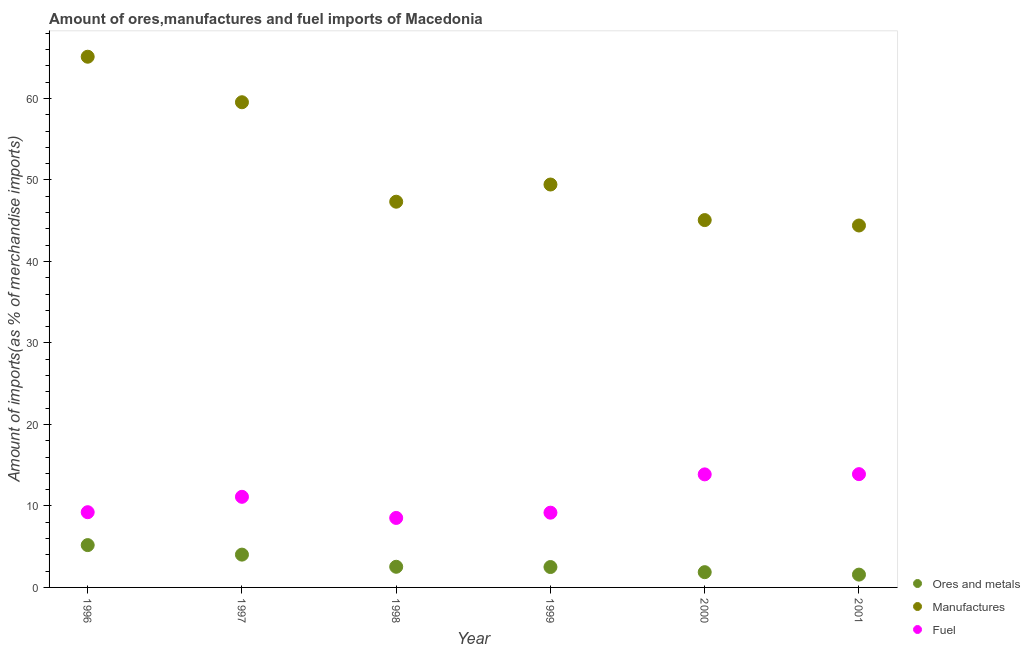How many different coloured dotlines are there?
Your answer should be compact. 3. Is the number of dotlines equal to the number of legend labels?
Ensure brevity in your answer.  Yes. What is the percentage of manufactures imports in 1996?
Your answer should be compact. 65.12. Across all years, what is the maximum percentage of manufactures imports?
Provide a succinct answer. 65.12. Across all years, what is the minimum percentage of ores and metals imports?
Provide a succinct answer. 1.57. What is the total percentage of fuel imports in the graph?
Offer a very short reply. 65.82. What is the difference between the percentage of fuel imports in 1997 and that in 1998?
Make the answer very short. 2.59. What is the difference between the percentage of ores and metals imports in 2000 and the percentage of fuel imports in 1996?
Make the answer very short. -7.36. What is the average percentage of fuel imports per year?
Offer a terse response. 10.97. In the year 2000, what is the difference between the percentage of fuel imports and percentage of ores and metals imports?
Provide a succinct answer. 12. In how many years, is the percentage of ores and metals imports greater than 52 %?
Offer a very short reply. 0. What is the ratio of the percentage of fuel imports in 1996 to that in 1998?
Provide a succinct answer. 1.08. Is the difference between the percentage of manufactures imports in 1998 and 1999 greater than the difference between the percentage of fuel imports in 1998 and 1999?
Ensure brevity in your answer.  No. What is the difference between the highest and the second highest percentage of fuel imports?
Your answer should be very brief. 0.03. What is the difference between the highest and the lowest percentage of ores and metals imports?
Provide a short and direct response. 3.62. In how many years, is the percentage of fuel imports greater than the average percentage of fuel imports taken over all years?
Offer a terse response. 3. Is the percentage of ores and metals imports strictly greater than the percentage of fuel imports over the years?
Make the answer very short. No. Is the percentage of manufactures imports strictly less than the percentage of ores and metals imports over the years?
Give a very brief answer. No. How many years are there in the graph?
Your answer should be very brief. 6. What is the difference between two consecutive major ticks on the Y-axis?
Provide a succinct answer. 10. Are the values on the major ticks of Y-axis written in scientific E-notation?
Your response must be concise. No. Where does the legend appear in the graph?
Make the answer very short. Bottom right. How many legend labels are there?
Your answer should be very brief. 3. How are the legend labels stacked?
Offer a terse response. Vertical. What is the title of the graph?
Make the answer very short. Amount of ores,manufactures and fuel imports of Macedonia. What is the label or title of the Y-axis?
Ensure brevity in your answer.  Amount of imports(as % of merchandise imports). What is the Amount of imports(as % of merchandise imports) in Ores and metals in 1996?
Ensure brevity in your answer.  5.19. What is the Amount of imports(as % of merchandise imports) in Manufactures in 1996?
Give a very brief answer. 65.12. What is the Amount of imports(as % of merchandise imports) in Fuel in 1996?
Offer a very short reply. 9.23. What is the Amount of imports(as % of merchandise imports) of Ores and metals in 1997?
Offer a terse response. 4.03. What is the Amount of imports(as % of merchandise imports) in Manufactures in 1997?
Your response must be concise. 59.54. What is the Amount of imports(as % of merchandise imports) in Fuel in 1997?
Make the answer very short. 11.12. What is the Amount of imports(as % of merchandise imports) of Ores and metals in 1998?
Provide a short and direct response. 2.53. What is the Amount of imports(as % of merchandise imports) of Manufactures in 1998?
Ensure brevity in your answer.  47.33. What is the Amount of imports(as % of merchandise imports) in Fuel in 1998?
Ensure brevity in your answer.  8.53. What is the Amount of imports(as % of merchandise imports) of Ores and metals in 1999?
Ensure brevity in your answer.  2.5. What is the Amount of imports(as % of merchandise imports) in Manufactures in 1999?
Make the answer very short. 49.44. What is the Amount of imports(as % of merchandise imports) of Fuel in 1999?
Make the answer very short. 9.17. What is the Amount of imports(as % of merchandise imports) of Ores and metals in 2000?
Give a very brief answer. 1.87. What is the Amount of imports(as % of merchandise imports) in Manufactures in 2000?
Your answer should be very brief. 45.08. What is the Amount of imports(as % of merchandise imports) in Fuel in 2000?
Make the answer very short. 13.87. What is the Amount of imports(as % of merchandise imports) of Ores and metals in 2001?
Give a very brief answer. 1.57. What is the Amount of imports(as % of merchandise imports) of Manufactures in 2001?
Offer a terse response. 44.41. What is the Amount of imports(as % of merchandise imports) of Fuel in 2001?
Ensure brevity in your answer.  13.9. Across all years, what is the maximum Amount of imports(as % of merchandise imports) in Ores and metals?
Give a very brief answer. 5.19. Across all years, what is the maximum Amount of imports(as % of merchandise imports) of Manufactures?
Provide a short and direct response. 65.12. Across all years, what is the maximum Amount of imports(as % of merchandise imports) of Fuel?
Provide a succinct answer. 13.9. Across all years, what is the minimum Amount of imports(as % of merchandise imports) in Ores and metals?
Provide a short and direct response. 1.57. Across all years, what is the minimum Amount of imports(as % of merchandise imports) in Manufactures?
Make the answer very short. 44.41. Across all years, what is the minimum Amount of imports(as % of merchandise imports) of Fuel?
Your answer should be compact. 8.53. What is the total Amount of imports(as % of merchandise imports) of Ores and metals in the graph?
Keep it short and to the point. 17.7. What is the total Amount of imports(as % of merchandise imports) of Manufactures in the graph?
Your answer should be very brief. 310.93. What is the total Amount of imports(as % of merchandise imports) of Fuel in the graph?
Offer a very short reply. 65.82. What is the difference between the Amount of imports(as % of merchandise imports) of Ores and metals in 1996 and that in 1997?
Make the answer very short. 1.17. What is the difference between the Amount of imports(as % of merchandise imports) in Manufactures in 1996 and that in 1997?
Keep it short and to the point. 5.59. What is the difference between the Amount of imports(as % of merchandise imports) in Fuel in 1996 and that in 1997?
Offer a terse response. -1.89. What is the difference between the Amount of imports(as % of merchandise imports) of Ores and metals in 1996 and that in 1998?
Your answer should be very brief. 2.66. What is the difference between the Amount of imports(as % of merchandise imports) of Manufactures in 1996 and that in 1998?
Ensure brevity in your answer.  17.79. What is the difference between the Amount of imports(as % of merchandise imports) of Fuel in 1996 and that in 1998?
Provide a succinct answer. 0.7. What is the difference between the Amount of imports(as % of merchandise imports) in Ores and metals in 1996 and that in 1999?
Make the answer very short. 2.69. What is the difference between the Amount of imports(as % of merchandise imports) in Manufactures in 1996 and that in 1999?
Keep it short and to the point. 15.68. What is the difference between the Amount of imports(as % of merchandise imports) in Fuel in 1996 and that in 1999?
Your response must be concise. 0.06. What is the difference between the Amount of imports(as % of merchandise imports) in Ores and metals in 1996 and that in 2000?
Give a very brief answer. 3.32. What is the difference between the Amount of imports(as % of merchandise imports) in Manufactures in 1996 and that in 2000?
Your answer should be very brief. 20.05. What is the difference between the Amount of imports(as % of merchandise imports) of Fuel in 1996 and that in 2000?
Your answer should be compact. -4.64. What is the difference between the Amount of imports(as % of merchandise imports) in Ores and metals in 1996 and that in 2001?
Provide a succinct answer. 3.62. What is the difference between the Amount of imports(as % of merchandise imports) in Manufactures in 1996 and that in 2001?
Provide a succinct answer. 20.71. What is the difference between the Amount of imports(as % of merchandise imports) of Fuel in 1996 and that in 2001?
Your response must be concise. -4.67. What is the difference between the Amount of imports(as % of merchandise imports) in Ores and metals in 1997 and that in 1998?
Provide a succinct answer. 1.49. What is the difference between the Amount of imports(as % of merchandise imports) of Manufactures in 1997 and that in 1998?
Ensure brevity in your answer.  12.21. What is the difference between the Amount of imports(as % of merchandise imports) of Fuel in 1997 and that in 1998?
Give a very brief answer. 2.59. What is the difference between the Amount of imports(as % of merchandise imports) in Ores and metals in 1997 and that in 1999?
Make the answer very short. 1.52. What is the difference between the Amount of imports(as % of merchandise imports) in Manufactures in 1997 and that in 1999?
Offer a very short reply. 10.1. What is the difference between the Amount of imports(as % of merchandise imports) of Fuel in 1997 and that in 1999?
Keep it short and to the point. 1.95. What is the difference between the Amount of imports(as % of merchandise imports) of Ores and metals in 1997 and that in 2000?
Your response must be concise. 2.15. What is the difference between the Amount of imports(as % of merchandise imports) in Manufactures in 1997 and that in 2000?
Offer a very short reply. 14.46. What is the difference between the Amount of imports(as % of merchandise imports) of Fuel in 1997 and that in 2000?
Keep it short and to the point. -2.75. What is the difference between the Amount of imports(as % of merchandise imports) in Ores and metals in 1997 and that in 2001?
Offer a very short reply. 2.45. What is the difference between the Amount of imports(as % of merchandise imports) of Manufactures in 1997 and that in 2001?
Offer a terse response. 15.13. What is the difference between the Amount of imports(as % of merchandise imports) of Fuel in 1997 and that in 2001?
Offer a very short reply. -2.78. What is the difference between the Amount of imports(as % of merchandise imports) in Manufactures in 1998 and that in 1999?
Offer a terse response. -2.11. What is the difference between the Amount of imports(as % of merchandise imports) of Fuel in 1998 and that in 1999?
Ensure brevity in your answer.  -0.65. What is the difference between the Amount of imports(as % of merchandise imports) of Ores and metals in 1998 and that in 2000?
Make the answer very short. 0.66. What is the difference between the Amount of imports(as % of merchandise imports) of Manufactures in 1998 and that in 2000?
Your response must be concise. 2.26. What is the difference between the Amount of imports(as % of merchandise imports) in Fuel in 1998 and that in 2000?
Provide a short and direct response. -5.34. What is the difference between the Amount of imports(as % of merchandise imports) in Manufactures in 1998 and that in 2001?
Your response must be concise. 2.92. What is the difference between the Amount of imports(as % of merchandise imports) in Fuel in 1998 and that in 2001?
Your answer should be very brief. -5.37. What is the difference between the Amount of imports(as % of merchandise imports) in Ores and metals in 1999 and that in 2000?
Give a very brief answer. 0.63. What is the difference between the Amount of imports(as % of merchandise imports) in Manufactures in 1999 and that in 2000?
Offer a very short reply. 4.37. What is the difference between the Amount of imports(as % of merchandise imports) in Fuel in 1999 and that in 2000?
Keep it short and to the point. -4.7. What is the difference between the Amount of imports(as % of merchandise imports) of Ores and metals in 1999 and that in 2001?
Give a very brief answer. 0.93. What is the difference between the Amount of imports(as % of merchandise imports) of Manufactures in 1999 and that in 2001?
Provide a succinct answer. 5.03. What is the difference between the Amount of imports(as % of merchandise imports) in Fuel in 1999 and that in 2001?
Provide a succinct answer. -4.73. What is the difference between the Amount of imports(as % of merchandise imports) of Ores and metals in 2000 and that in 2001?
Provide a succinct answer. 0.3. What is the difference between the Amount of imports(as % of merchandise imports) in Manufactures in 2000 and that in 2001?
Your answer should be very brief. 0.66. What is the difference between the Amount of imports(as % of merchandise imports) of Fuel in 2000 and that in 2001?
Your response must be concise. -0.03. What is the difference between the Amount of imports(as % of merchandise imports) of Ores and metals in 1996 and the Amount of imports(as % of merchandise imports) of Manufactures in 1997?
Offer a terse response. -54.35. What is the difference between the Amount of imports(as % of merchandise imports) of Ores and metals in 1996 and the Amount of imports(as % of merchandise imports) of Fuel in 1997?
Offer a very short reply. -5.93. What is the difference between the Amount of imports(as % of merchandise imports) of Manufactures in 1996 and the Amount of imports(as % of merchandise imports) of Fuel in 1997?
Provide a succinct answer. 54.01. What is the difference between the Amount of imports(as % of merchandise imports) in Ores and metals in 1996 and the Amount of imports(as % of merchandise imports) in Manufactures in 1998?
Provide a succinct answer. -42.14. What is the difference between the Amount of imports(as % of merchandise imports) in Ores and metals in 1996 and the Amount of imports(as % of merchandise imports) in Fuel in 1998?
Make the answer very short. -3.33. What is the difference between the Amount of imports(as % of merchandise imports) of Manufactures in 1996 and the Amount of imports(as % of merchandise imports) of Fuel in 1998?
Offer a terse response. 56.6. What is the difference between the Amount of imports(as % of merchandise imports) in Ores and metals in 1996 and the Amount of imports(as % of merchandise imports) in Manufactures in 1999?
Keep it short and to the point. -44.25. What is the difference between the Amount of imports(as % of merchandise imports) of Ores and metals in 1996 and the Amount of imports(as % of merchandise imports) of Fuel in 1999?
Your answer should be very brief. -3.98. What is the difference between the Amount of imports(as % of merchandise imports) in Manufactures in 1996 and the Amount of imports(as % of merchandise imports) in Fuel in 1999?
Ensure brevity in your answer.  55.95. What is the difference between the Amount of imports(as % of merchandise imports) in Ores and metals in 1996 and the Amount of imports(as % of merchandise imports) in Manufactures in 2000?
Offer a terse response. -39.88. What is the difference between the Amount of imports(as % of merchandise imports) in Ores and metals in 1996 and the Amount of imports(as % of merchandise imports) in Fuel in 2000?
Provide a short and direct response. -8.68. What is the difference between the Amount of imports(as % of merchandise imports) of Manufactures in 1996 and the Amount of imports(as % of merchandise imports) of Fuel in 2000?
Provide a succinct answer. 51.25. What is the difference between the Amount of imports(as % of merchandise imports) of Ores and metals in 1996 and the Amount of imports(as % of merchandise imports) of Manufactures in 2001?
Provide a short and direct response. -39.22. What is the difference between the Amount of imports(as % of merchandise imports) in Ores and metals in 1996 and the Amount of imports(as % of merchandise imports) in Fuel in 2001?
Your answer should be very brief. -8.71. What is the difference between the Amount of imports(as % of merchandise imports) of Manufactures in 1996 and the Amount of imports(as % of merchandise imports) of Fuel in 2001?
Offer a terse response. 51.22. What is the difference between the Amount of imports(as % of merchandise imports) in Ores and metals in 1997 and the Amount of imports(as % of merchandise imports) in Manufactures in 1998?
Provide a succinct answer. -43.31. What is the difference between the Amount of imports(as % of merchandise imports) of Ores and metals in 1997 and the Amount of imports(as % of merchandise imports) of Fuel in 1998?
Keep it short and to the point. -4.5. What is the difference between the Amount of imports(as % of merchandise imports) of Manufactures in 1997 and the Amount of imports(as % of merchandise imports) of Fuel in 1998?
Your answer should be very brief. 51.01. What is the difference between the Amount of imports(as % of merchandise imports) of Ores and metals in 1997 and the Amount of imports(as % of merchandise imports) of Manufactures in 1999?
Make the answer very short. -45.42. What is the difference between the Amount of imports(as % of merchandise imports) of Ores and metals in 1997 and the Amount of imports(as % of merchandise imports) of Fuel in 1999?
Provide a succinct answer. -5.15. What is the difference between the Amount of imports(as % of merchandise imports) in Manufactures in 1997 and the Amount of imports(as % of merchandise imports) in Fuel in 1999?
Keep it short and to the point. 50.37. What is the difference between the Amount of imports(as % of merchandise imports) in Ores and metals in 1997 and the Amount of imports(as % of merchandise imports) in Manufactures in 2000?
Keep it short and to the point. -41.05. What is the difference between the Amount of imports(as % of merchandise imports) of Ores and metals in 1997 and the Amount of imports(as % of merchandise imports) of Fuel in 2000?
Give a very brief answer. -9.85. What is the difference between the Amount of imports(as % of merchandise imports) of Manufactures in 1997 and the Amount of imports(as % of merchandise imports) of Fuel in 2000?
Your answer should be compact. 45.67. What is the difference between the Amount of imports(as % of merchandise imports) of Ores and metals in 1997 and the Amount of imports(as % of merchandise imports) of Manufactures in 2001?
Your response must be concise. -40.39. What is the difference between the Amount of imports(as % of merchandise imports) in Ores and metals in 1997 and the Amount of imports(as % of merchandise imports) in Fuel in 2001?
Your answer should be very brief. -9.88. What is the difference between the Amount of imports(as % of merchandise imports) of Manufactures in 1997 and the Amount of imports(as % of merchandise imports) of Fuel in 2001?
Make the answer very short. 45.64. What is the difference between the Amount of imports(as % of merchandise imports) in Ores and metals in 1998 and the Amount of imports(as % of merchandise imports) in Manufactures in 1999?
Give a very brief answer. -46.91. What is the difference between the Amount of imports(as % of merchandise imports) of Ores and metals in 1998 and the Amount of imports(as % of merchandise imports) of Fuel in 1999?
Keep it short and to the point. -6.64. What is the difference between the Amount of imports(as % of merchandise imports) of Manufactures in 1998 and the Amount of imports(as % of merchandise imports) of Fuel in 1999?
Make the answer very short. 38.16. What is the difference between the Amount of imports(as % of merchandise imports) of Ores and metals in 1998 and the Amount of imports(as % of merchandise imports) of Manufactures in 2000?
Keep it short and to the point. -42.54. What is the difference between the Amount of imports(as % of merchandise imports) in Ores and metals in 1998 and the Amount of imports(as % of merchandise imports) in Fuel in 2000?
Keep it short and to the point. -11.34. What is the difference between the Amount of imports(as % of merchandise imports) in Manufactures in 1998 and the Amount of imports(as % of merchandise imports) in Fuel in 2000?
Give a very brief answer. 33.46. What is the difference between the Amount of imports(as % of merchandise imports) of Ores and metals in 1998 and the Amount of imports(as % of merchandise imports) of Manufactures in 2001?
Ensure brevity in your answer.  -41.88. What is the difference between the Amount of imports(as % of merchandise imports) in Ores and metals in 1998 and the Amount of imports(as % of merchandise imports) in Fuel in 2001?
Provide a short and direct response. -11.37. What is the difference between the Amount of imports(as % of merchandise imports) in Manufactures in 1998 and the Amount of imports(as % of merchandise imports) in Fuel in 2001?
Offer a terse response. 33.43. What is the difference between the Amount of imports(as % of merchandise imports) of Ores and metals in 1999 and the Amount of imports(as % of merchandise imports) of Manufactures in 2000?
Offer a terse response. -42.57. What is the difference between the Amount of imports(as % of merchandise imports) in Ores and metals in 1999 and the Amount of imports(as % of merchandise imports) in Fuel in 2000?
Provide a short and direct response. -11.37. What is the difference between the Amount of imports(as % of merchandise imports) of Manufactures in 1999 and the Amount of imports(as % of merchandise imports) of Fuel in 2000?
Your answer should be compact. 35.57. What is the difference between the Amount of imports(as % of merchandise imports) of Ores and metals in 1999 and the Amount of imports(as % of merchandise imports) of Manufactures in 2001?
Your answer should be compact. -41.91. What is the difference between the Amount of imports(as % of merchandise imports) of Ores and metals in 1999 and the Amount of imports(as % of merchandise imports) of Fuel in 2001?
Offer a terse response. -11.4. What is the difference between the Amount of imports(as % of merchandise imports) in Manufactures in 1999 and the Amount of imports(as % of merchandise imports) in Fuel in 2001?
Provide a short and direct response. 35.54. What is the difference between the Amount of imports(as % of merchandise imports) of Ores and metals in 2000 and the Amount of imports(as % of merchandise imports) of Manufactures in 2001?
Your answer should be compact. -42.54. What is the difference between the Amount of imports(as % of merchandise imports) of Ores and metals in 2000 and the Amount of imports(as % of merchandise imports) of Fuel in 2001?
Make the answer very short. -12.03. What is the difference between the Amount of imports(as % of merchandise imports) in Manufactures in 2000 and the Amount of imports(as % of merchandise imports) in Fuel in 2001?
Offer a very short reply. 31.18. What is the average Amount of imports(as % of merchandise imports) of Ores and metals per year?
Provide a short and direct response. 2.95. What is the average Amount of imports(as % of merchandise imports) in Manufactures per year?
Provide a succinct answer. 51.82. What is the average Amount of imports(as % of merchandise imports) of Fuel per year?
Give a very brief answer. 10.97. In the year 1996, what is the difference between the Amount of imports(as % of merchandise imports) in Ores and metals and Amount of imports(as % of merchandise imports) in Manufactures?
Your response must be concise. -59.93. In the year 1996, what is the difference between the Amount of imports(as % of merchandise imports) of Ores and metals and Amount of imports(as % of merchandise imports) of Fuel?
Ensure brevity in your answer.  -4.04. In the year 1996, what is the difference between the Amount of imports(as % of merchandise imports) in Manufactures and Amount of imports(as % of merchandise imports) in Fuel?
Ensure brevity in your answer.  55.89. In the year 1997, what is the difference between the Amount of imports(as % of merchandise imports) of Ores and metals and Amount of imports(as % of merchandise imports) of Manufactures?
Your answer should be compact. -55.51. In the year 1997, what is the difference between the Amount of imports(as % of merchandise imports) in Ores and metals and Amount of imports(as % of merchandise imports) in Fuel?
Your answer should be very brief. -7.09. In the year 1997, what is the difference between the Amount of imports(as % of merchandise imports) of Manufactures and Amount of imports(as % of merchandise imports) of Fuel?
Ensure brevity in your answer.  48.42. In the year 1998, what is the difference between the Amount of imports(as % of merchandise imports) of Ores and metals and Amount of imports(as % of merchandise imports) of Manufactures?
Ensure brevity in your answer.  -44.8. In the year 1998, what is the difference between the Amount of imports(as % of merchandise imports) in Ores and metals and Amount of imports(as % of merchandise imports) in Fuel?
Ensure brevity in your answer.  -5.99. In the year 1998, what is the difference between the Amount of imports(as % of merchandise imports) of Manufactures and Amount of imports(as % of merchandise imports) of Fuel?
Your response must be concise. 38.8. In the year 1999, what is the difference between the Amount of imports(as % of merchandise imports) in Ores and metals and Amount of imports(as % of merchandise imports) in Manufactures?
Offer a terse response. -46.94. In the year 1999, what is the difference between the Amount of imports(as % of merchandise imports) of Ores and metals and Amount of imports(as % of merchandise imports) of Fuel?
Provide a succinct answer. -6.67. In the year 1999, what is the difference between the Amount of imports(as % of merchandise imports) in Manufactures and Amount of imports(as % of merchandise imports) in Fuel?
Your answer should be compact. 40.27. In the year 2000, what is the difference between the Amount of imports(as % of merchandise imports) in Ores and metals and Amount of imports(as % of merchandise imports) in Manufactures?
Give a very brief answer. -43.2. In the year 2000, what is the difference between the Amount of imports(as % of merchandise imports) in Ores and metals and Amount of imports(as % of merchandise imports) in Fuel?
Provide a succinct answer. -12. In the year 2000, what is the difference between the Amount of imports(as % of merchandise imports) of Manufactures and Amount of imports(as % of merchandise imports) of Fuel?
Offer a terse response. 31.21. In the year 2001, what is the difference between the Amount of imports(as % of merchandise imports) in Ores and metals and Amount of imports(as % of merchandise imports) in Manufactures?
Ensure brevity in your answer.  -42.84. In the year 2001, what is the difference between the Amount of imports(as % of merchandise imports) in Ores and metals and Amount of imports(as % of merchandise imports) in Fuel?
Give a very brief answer. -12.33. In the year 2001, what is the difference between the Amount of imports(as % of merchandise imports) of Manufactures and Amount of imports(as % of merchandise imports) of Fuel?
Ensure brevity in your answer.  30.51. What is the ratio of the Amount of imports(as % of merchandise imports) in Ores and metals in 1996 to that in 1997?
Ensure brevity in your answer.  1.29. What is the ratio of the Amount of imports(as % of merchandise imports) of Manufactures in 1996 to that in 1997?
Your answer should be very brief. 1.09. What is the ratio of the Amount of imports(as % of merchandise imports) of Fuel in 1996 to that in 1997?
Offer a terse response. 0.83. What is the ratio of the Amount of imports(as % of merchandise imports) of Ores and metals in 1996 to that in 1998?
Offer a very short reply. 2.05. What is the ratio of the Amount of imports(as % of merchandise imports) of Manufactures in 1996 to that in 1998?
Your answer should be very brief. 1.38. What is the ratio of the Amount of imports(as % of merchandise imports) in Fuel in 1996 to that in 1998?
Ensure brevity in your answer.  1.08. What is the ratio of the Amount of imports(as % of merchandise imports) of Ores and metals in 1996 to that in 1999?
Give a very brief answer. 2.07. What is the ratio of the Amount of imports(as % of merchandise imports) in Manufactures in 1996 to that in 1999?
Make the answer very short. 1.32. What is the ratio of the Amount of imports(as % of merchandise imports) in Ores and metals in 1996 to that in 2000?
Make the answer very short. 2.77. What is the ratio of the Amount of imports(as % of merchandise imports) of Manufactures in 1996 to that in 2000?
Provide a succinct answer. 1.44. What is the ratio of the Amount of imports(as % of merchandise imports) in Fuel in 1996 to that in 2000?
Keep it short and to the point. 0.67. What is the ratio of the Amount of imports(as % of merchandise imports) in Ores and metals in 1996 to that in 2001?
Ensure brevity in your answer.  3.3. What is the ratio of the Amount of imports(as % of merchandise imports) in Manufactures in 1996 to that in 2001?
Your answer should be very brief. 1.47. What is the ratio of the Amount of imports(as % of merchandise imports) in Fuel in 1996 to that in 2001?
Keep it short and to the point. 0.66. What is the ratio of the Amount of imports(as % of merchandise imports) in Ores and metals in 1997 to that in 1998?
Your response must be concise. 1.59. What is the ratio of the Amount of imports(as % of merchandise imports) of Manufactures in 1997 to that in 1998?
Your answer should be compact. 1.26. What is the ratio of the Amount of imports(as % of merchandise imports) in Fuel in 1997 to that in 1998?
Your answer should be compact. 1.3. What is the ratio of the Amount of imports(as % of merchandise imports) of Ores and metals in 1997 to that in 1999?
Keep it short and to the point. 1.61. What is the ratio of the Amount of imports(as % of merchandise imports) of Manufactures in 1997 to that in 1999?
Offer a very short reply. 1.2. What is the ratio of the Amount of imports(as % of merchandise imports) of Fuel in 1997 to that in 1999?
Your answer should be compact. 1.21. What is the ratio of the Amount of imports(as % of merchandise imports) of Ores and metals in 1997 to that in 2000?
Your response must be concise. 2.15. What is the ratio of the Amount of imports(as % of merchandise imports) in Manufactures in 1997 to that in 2000?
Offer a very short reply. 1.32. What is the ratio of the Amount of imports(as % of merchandise imports) of Fuel in 1997 to that in 2000?
Your answer should be compact. 0.8. What is the ratio of the Amount of imports(as % of merchandise imports) of Ores and metals in 1997 to that in 2001?
Offer a very short reply. 2.56. What is the ratio of the Amount of imports(as % of merchandise imports) of Manufactures in 1997 to that in 2001?
Keep it short and to the point. 1.34. What is the ratio of the Amount of imports(as % of merchandise imports) in Fuel in 1997 to that in 2001?
Keep it short and to the point. 0.8. What is the ratio of the Amount of imports(as % of merchandise imports) in Manufactures in 1998 to that in 1999?
Offer a terse response. 0.96. What is the ratio of the Amount of imports(as % of merchandise imports) of Fuel in 1998 to that in 1999?
Keep it short and to the point. 0.93. What is the ratio of the Amount of imports(as % of merchandise imports) in Ores and metals in 1998 to that in 2000?
Provide a succinct answer. 1.35. What is the ratio of the Amount of imports(as % of merchandise imports) of Fuel in 1998 to that in 2000?
Your answer should be compact. 0.61. What is the ratio of the Amount of imports(as % of merchandise imports) in Ores and metals in 1998 to that in 2001?
Provide a short and direct response. 1.61. What is the ratio of the Amount of imports(as % of merchandise imports) of Manufactures in 1998 to that in 2001?
Your answer should be compact. 1.07. What is the ratio of the Amount of imports(as % of merchandise imports) of Fuel in 1998 to that in 2001?
Provide a short and direct response. 0.61. What is the ratio of the Amount of imports(as % of merchandise imports) in Ores and metals in 1999 to that in 2000?
Offer a very short reply. 1.34. What is the ratio of the Amount of imports(as % of merchandise imports) in Manufactures in 1999 to that in 2000?
Give a very brief answer. 1.1. What is the ratio of the Amount of imports(as % of merchandise imports) in Fuel in 1999 to that in 2000?
Provide a succinct answer. 0.66. What is the ratio of the Amount of imports(as % of merchandise imports) of Ores and metals in 1999 to that in 2001?
Provide a short and direct response. 1.59. What is the ratio of the Amount of imports(as % of merchandise imports) in Manufactures in 1999 to that in 2001?
Make the answer very short. 1.11. What is the ratio of the Amount of imports(as % of merchandise imports) in Fuel in 1999 to that in 2001?
Ensure brevity in your answer.  0.66. What is the ratio of the Amount of imports(as % of merchandise imports) in Ores and metals in 2000 to that in 2001?
Your answer should be very brief. 1.19. What is the ratio of the Amount of imports(as % of merchandise imports) in Manufactures in 2000 to that in 2001?
Your response must be concise. 1.01. What is the ratio of the Amount of imports(as % of merchandise imports) in Fuel in 2000 to that in 2001?
Your response must be concise. 1. What is the difference between the highest and the second highest Amount of imports(as % of merchandise imports) of Ores and metals?
Offer a terse response. 1.17. What is the difference between the highest and the second highest Amount of imports(as % of merchandise imports) of Manufactures?
Make the answer very short. 5.59. What is the difference between the highest and the second highest Amount of imports(as % of merchandise imports) in Fuel?
Ensure brevity in your answer.  0.03. What is the difference between the highest and the lowest Amount of imports(as % of merchandise imports) of Ores and metals?
Your answer should be very brief. 3.62. What is the difference between the highest and the lowest Amount of imports(as % of merchandise imports) of Manufactures?
Provide a succinct answer. 20.71. What is the difference between the highest and the lowest Amount of imports(as % of merchandise imports) in Fuel?
Your answer should be compact. 5.37. 